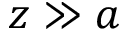<formula> <loc_0><loc_0><loc_500><loc_500>z \gg a</formula> 